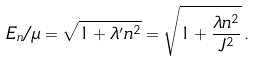Convert formula to latex. <formula><loc_0><loc_0><loc_500><loc_500>E _ { n } / \mu = \sqrt { 1 + \lambda ^ { \prime } { n ^ { 2 } } } = \sqrt { 1 + \frac { \lambda n ^ { 2 } } { J ^ { 2 } } } \, .</formula> 